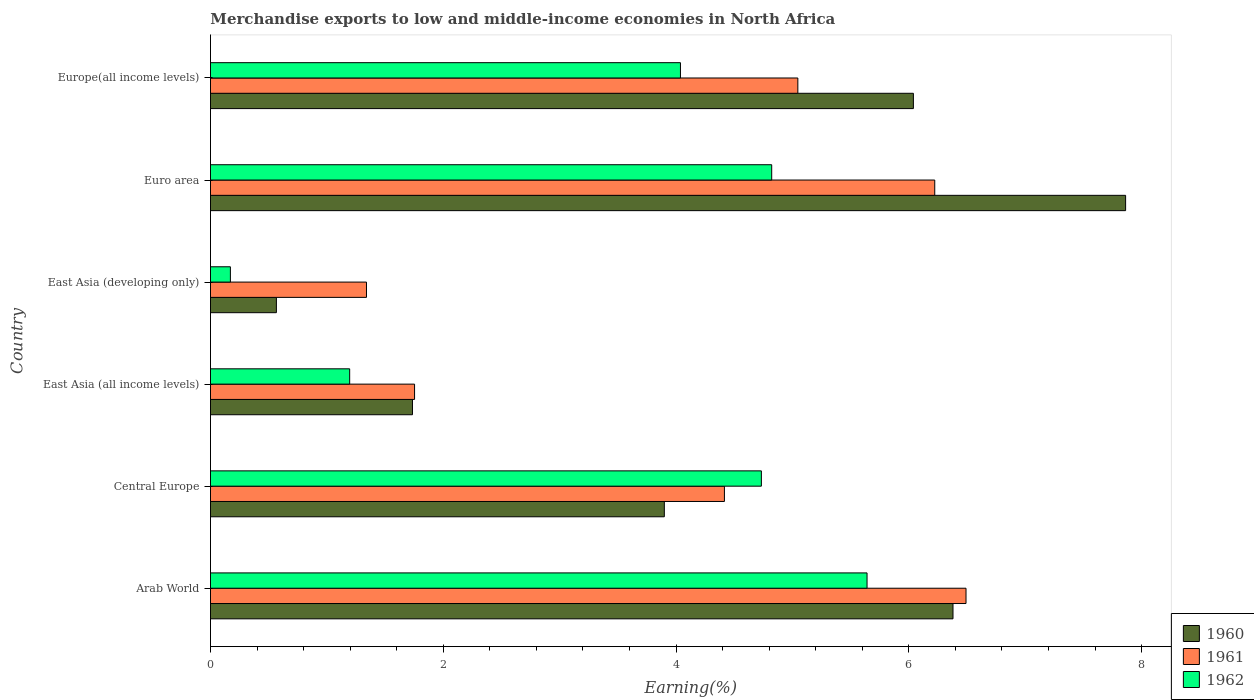How many groups of bars are there?
Offer a terse response. 6. Are the number of bars per tick equal to the number of legend labels?
Your response must be concise. Yes. Are the number of bars on each tick of the Y-axis equal?
Give a very brief answer. Yes. How many bars are there on the 3rd tick from the top?
Your response must be concise. 3. What is the label of the 4th group of bars from the top?
Your answer should be very brief. East Asia (all income levels). In how many cases, is the number of bars for a given country not equal to the number of legend labels?
Your answer should be compact. 0. What is the percentage of amount earned from merchandise exports in 1962 in Europe(all income levels)?
Your response must be concise. 4.04. Across all countries, what is the maximum percentage of amount earned from merchandise exports in 1961?
Your response must be concise. 6.49. Across all countries, what is the minimum percentage of amount earned from merchandise exports in 1960?
Ensure brevity in your answer.  0.57. In which country was the percentage of amount earned from merchandise exports in 1961 maximum?
Your answer should be very brief. Arab World. In which country was the percentage of amount earned from merchandise exports in 1960 minimum?
Give a very brief answer. East Asia (developing only). What is the total percentage of amount earned from merchandise exports in 1962 in the graph?
Your answer should be very brief. 20.6. What is the difference between the percentage of amount earned from merchandise exports in 1962 in Arab World and that in Euro area?
Provide a short and direct response. 0.82. What is the difference between the percentage of amount earned from merchandise exports in 1962 in Euro area and the percentage of amount earned from merchandise exports in 1960 in East Asia (all income levels)?
Offer a very short reply. 3.09. What is the average percentage of amount earned from merchandise exports in 1961 per country?
Ensure brevity in your answer.  4.21. What is the difference between the percentage of amount earned from merchandise exports in 1962 and percentage of amount earned from merchandise exports in 1961 in Central Europe?
Make the answer very short. 0.32. What is the ratio of the percentage of amount earned from merchandise exports in 1962 in East Asia (all income levels) to that in Europe(all income levels)?
Ensure brevity in your answer.  0.3. Is the difference between the percentage of amount earned from merchandise exports in 1962 in East Asia (all income levels) and Euro area greater than the difference between the percentage of amount earned from merchandise exports in 1961 in East Asia (all income levels) and Euro area?
Your response must be concise. Yes. What is the difference between the highest and the second highest percentage of amount earned from merchandise exports in 1962?
Ensure brevity in your answer.  0.82. What is the difference between the highest and the lowest percentage of amount earned from merchandise exports in 1960?
Keep it short and to the point. 7.3. How many countries are there in the graph?
Offer a very short reply. 6. What is the difference between two consecutive major ticks on the X-axis?
Make the answer very short. 2. Does the graph contain any zero values?
Ensure brevity in your answer.  No. What is the title of the graph?
Your answer should be very brief. Merchandise exports to low and middle-income economies in North Africa. What is the label or title of the X-axis?
Provide a short and direct response. Earning(%). What is the Earning(%) of 1960 in Arab World?
Provide a succinct answer. 6.38. What is the Earning(%) in 1961 in Arab World?
Your answer should be compact. 6.49. What is the Earning(%) of 1962 in Arab World?
Keep it short and to the point. 5.64. What is the Earning(%) in 1960 in Central Europe?
Give a very brief answer. 3.9. What is the Earning(%) of 1961 in Central Europe?
Keep it short and to the point. 4.42. What is the Earning(%) of 1962 in Central Europe?
Provide a short and direct response. 4.73. What is the Earning(%) of 1960 in East Asia (all income levels)?
Keep it short and to the point. 1.74. What is the Earning(%) of 1961 in East Asia (all income levels)?
Your response must be concise. 1.75. What is the Earning(%) in 1962 in East Asia (all income levels)?
Give a very brief answer. 1.2. What is the Earning(%) in 1960 in East Asia (developing only)?
Ensure brevity in your answer.  0.57. What is the Earning(%) in 1961 in East Asia (developing only)?
Make the answer very short. 1.34. What is the Earning(%) of 1962 in East Asia (developing only)?
Provide a succinct answer. 0.17. What is the Earning(%) of 1960 in Euro area?
Your response must be concise. 7.86. What is the Earning(%) in 1961 in Euro area?
Your response must be concise. 6.22. What is the Earning(%) of 1962 in Euro area?
Provide a succinct answer. 4.82. What is the Earning(%) of 1960 in Europe(all income levels)?
Offer a terse response. 6.04. What is the Earning(%) in 1961 in Europe(all income levels)?
Offer a terse response. 5.05. What is the Earning(%) in 1962 in Europe(all income levels)?
Offer a very short reply. 4.04. Across all countries, what is the maximum Earning(%) of 1960?
Offer a very short reply. 7.86. Across all countries, what is the maximum Earning(%) of 1961?
Your answer should be compact. 6.49. Across all countries, what is the maximum Earning(%) of 1962?
Your answer should be very brief. 5.64. Across all countries, what is the minimum Earning(%) in 1960?
Offer a terse response. 0.57. Across all countries, what is the minimum Earning(%) of 1961?
Make the answer very short. 1.34. Across all countries, what is the minimum Earning(%) of 1962?
Ensure brevity in your answer.  0.17. What is the total Earning(%) in 1960 in the graph?
Offer a very short reply. 26.48. What is the total Earning(%) in 1961 in the graph?
Keep it short and to the point. 25.27. What is the total Earning(%) of 1962 in the graph?
Offer a terse response. 20.6. What is the difference between the Earning(%) of 1960 in Arab World and that in Central Europe?
Offer a very short reply. 2.48. What is the difference between the Earning(%) in 1961 in Arab World and that in Central Europe?
Your answer should be compact. 2.08. What is the difference between the Earning(%) in 1962 in Arab World and that in Central Europe?
Make the answer very short. 0.91. What is the difference between the Earning(%) in 1960 in Arab World and that in East Asia (all income levels)?
Provide a short and direct response. 4.64. What is the difference between the Earning(%) in 1961 in Arab World and that in East Asia (all income levels)?
Your answer should be compact. 4.74. What is the difference between the Earning(%) of 1962 in Arab World and that in East Asia (all income levels)?
Offer a terse response. 4.45. What is the difference between the Earning(%) in 1960 in Arab World and that in East Asia (developing only)?
Your answer should be very brief. 5.81. What is the difference between the Earning(%) of 1961 in Arab World and that in East Asia (developing only)?
Your answer should be compact. 5.15. What is the difference between the Earning(%) of 1962 in Arab World and that in East Asia (developing only)?
Your response must be concise. 5.47. What is the difference between the Earning(%) in 1960 in Arab World and that in Euro area?
Keep it short and to the point. -1.48. What is the difference between the Earning(%) in 1961 in Arab World and that in Euro area?
Offer a terse response. 0.27. What is the difference between the Earning(%) in 1962 in Arab World and that in Euro area?
Provide a short and direct response. 0.82. What is the difference between the Earning(%) in 1960 in Arab World and that in Europe(all income levels)?
Your answer should be very brief. 0.34. What is the difference between the Earning(%) in 1961 in Arab World and that in Europe(all income levels)?
Offer a terse response. 1.44. What is the difference between the Earning(%) of 1962 in Arab World and that in Europe(all income levels)?
Ensure brevity in your answer.  1.6. What is the difference between the Earning(%) in 1960 in Central Europe and that in East Asia (all income levels)?
Provide a succinct answer. 2.16. What is the difference between the Earning(%) in 1961 in Central Europe and that in East Asia (all income levels)?
Offer a very short reply. 2.66. What is the difference between the Earning(%) in 1962 in Central Europe and that in East Asia (all income levels)?
Offer a very short reply. 3.54. What is the difference between the Earning(%) of 1960 in Central Europe and that in East Asia (developing only)?
Offer a very short reply. 3.33. What is the difference between the Earning(%) of 1961 in Central Europe and that in East Asia (developing only)?
Provide a short and direct response. 3.08. What is the difference between the Earning(%) of 1962 in Central Europe and that in East Asia (developing only)?
Your answer should be very brief. 4.56. What is the difference between the Earning(%) of 1960 in Central Europe and that in Euro area?
Make the answer very short. -3.96. What is the difference between the Earning(%) in 1961 in Central Europe and that in Euro area?
Provide a succinct answer. -1.81. What is the difference between the Earning(%) in 1962 in Central Europe and that in Euro area?
Ensure brevity in your answer.  -0.09. What is the difference between the Earning(%) in 1960 in Central Europe and that in Europe(all income levels)?
Ensure brevity in your answer.  -2.14. What is the difference between the Earning(%) of 1961 in Central Europe and that in Europe(all income levels)?
Provide a succinct answer. -0.63. What is the difference between the Earning(%) of 1962 in Central Europe and that in Europe(all income levels)?
Provide a succinct answer. 0.7. What is the difference between the Earning(%) in 1960 in East Asia (all income levels) and that in East Asia (developing only)?
Provide a short and direct response. 1.17. What is the difference between the Earning(%) of 1961 in East Asia (all income levels) and that in East Asia (developing only)?
Provide a succinct answer. 0.41. What is the difference between the Earning(%) of 1962 in East Asia (all income levels) and that in East Asia (developing only)?
Provide a short and direct response. 1.02. What is the difference between the Earning(%) in 1960 in East Asia (all income levels) and that in Euro area?
Your answer should be compact. -6.13. What is the difference between the Earning(%) in 1961 in East Asia (all income levels) and that in Euro area?
Offer a terse response. -4.47. What is the difference between the Earning(%) in 1962 in East Asia (all income levels) and that in Euro area?
Offer a terse response. -3.63. What is the difference between the Earning(%) in 1960 in East Asia (all income levels) and that in Europe(all income levels)?
Provide a short and direct response. -4.3. What is the difference between the Earning(%) in 1961 in East Asia (all income levels) and that in Europe(all income levels)?
Your answer should be compact. -3.29. What is the difference between the Earning(%) in 1962 in East Asia (all income levels) and that in Europe(all income levels)?
Offer a very short reply. -2.84. What is the difference between the Earning(%) of 1960 in East Asia (developing only) and that in Euro area?
Your answer should be compact. -7.3. What is the difference between the Earning(%) in 1961 in East Asia (developing only) and that in Euro area?
Ensure brevity in your answer.  -4.88. What is the difference between the Earning(%) in 1962 in East Asia (developing only) and that in Euro area?
Offer a very short reply. -4.65. What is the difference between the Earning(%) of 1960 in East Asia (developing only) and that in Europe(all income levels)?
Provide a short and direct response. -5.47. What is the difference between the Earning(%) of 1961 in East Asia (developing only) and that in Europe(all income levels)?
Keep it short and to the point. -3.71. What is the difference between the Earning(%) in 1962 in East Asia (developing only) and that in Europe(all income levels)?
Keep it short and to the point. -3.87. What is the difference between the Earning(%) of 1960 in Euro area and that in Europe(all income levels)?
Ensure brevity in your answer.  1.82. What is the difference between the Earning(%) of 1961 in Euro area and that in Europe(all income levels)?
Give a very brief answer. 1.18. What is the difference between the Earning(%) of 1962 in Euro area and that in Europe(all income levels)?
Your answer should be compact. 0.78. What is the difference between the Earning(%) of 1960 in Arab World and the Earning(%) of 1961 in Central Europe?
Your response must be concise. 1.96. What is the difference between the Earning(%) in 1960 in Arab World and the Earning(%) in 1962 in Central Europe?
Your answer should be very brief. 1.65. What is the difference between the Earning(%) of 1961 in Arab World and the Earning(%) of 1962 in Central Europe?
Your answer should be compact. 1.76. What is the difference between the Earning(%) of 1960 in Arab World and the Earning(%) of 1961 in East Asia (all income levels)?
Offer a very short reply. 4.63. What is the difference between the Earning(%) in 1960 in Arab World and the Earning(%) in 1962 in East Asia (all income levels)?
Provide a succinct answer. 5.18. What is the difference between the Earning(%) in 1961 in Arab World and the Earning(%) in 1962 in East Asia (all income levels)?
Offer a very short reply. 5.3. What is the difference between the Earning(%) of 1960 in Arab World and the Earning(%) of 1961 in East Asia (developing only)?
Your response must be concise. 5.04. What is the difference between the Earning(%) of 1960 in Arab World and the Earning(%) of 1962 in East Asia (developing only)?
Give a very brief answer. 6.21. What is the difference between the Earning(%) in 1961 in Arab World and the Earning(%) in 1962 in East Asia (developing only)?
Make the answer very short. 6.32. What is the difference between the Earning(%) in 1960 in Arab World and the Earning(%) in 1961 in Euro area?
Your answer should be compact. 0.16. What is the difference between the Earning(%) of 1960 in Arab World and the Earning(%) of 1962 in Euro area?
Provide a succinct answer. 1.56. What is the difference between the Earning(%) of 1961 in Arab World and the Earning(%) of 1962 in Euro area?
Your response must be concise. 1.67. What is the difference between the Earning(%) in 1960 in Arab World and the Earning(%) in 1961 in Europe(all income levels)?
Provide a succinct answer. 1.33. What is the difference between the Earning(%) in 1960 in Arab World and the Earning(%) in 1962 in Europe(all income levels)?
Keep it short and to the point. 2.34. What is the difference between the Earning(%) of 1961 in Arab World and the Earning(%) of 1962 in Europe(all income levels)?
Offer a very short reply. 2.45. What is the difference between the Earning(%) in 1960 in Central Europe and the Earning(%) in 1961 in East Asia (all income levels)?
Your answer should be very brief. 2.15. What is the difference between the Earning(%) in 1960 in Central Europe and the Earning(%) in 1962 in East Asia (all income levels)?
Provide a succinct answer. 2.7. What is the difference between the Earning(%) in 1961 in Central Europe and the Earning(%) in 1962 in East Asia (all income levels)?
Your answer should be very brief. 3.22. What is the difference between the Earning(%) of 1960 in Central Europe and the Earning(%) of 1961 in East Asia (developing only)?
Offer a very short reply. 2.56. What is the difference between the Earning(%) in 1960 in Central Europe and the Earning(%) in 1962 in East Asia (developing only)?
Offer a terse response. 3.73. What is the difference between the Earning(%) in 1961 in Central Europe and the Earning(%) in 1962 in East Asia (developing only)?
Give a very brief answer. 4.24. What is the difference between the Earning(%) of 1960 in Central Europe and the Earning(%) of 1961 in Euro area?
Offer a terse response. -2.32. What is the difference between the Earning(%) in 1960 in Central Europe and the Earning(%) in 1962 in Euro area?
Keep it short and to the point. -0.92. What is the difference between the Earning(%) in 1961 in Central Europe and the Earning(%) in 1962 in Euro area?
Provide a succinct answer. -0.41. What is the difference between the Earning(%) in 1960 in Central Europe and the Earning(%) in 1961 in Europe(all income levels)?
Offer a terse response. -1.15. What is the difference between the Earning(%) in 1960 in Central Europe and the Earning(%) in 1962 in Europe(all income levels)?
Offer a terse response. -0.14. What is the difference between the Earning(%) in 1961 in Central Europe and the Earning(%) in 1962 in Europe(all income levels)?
Offer a very short reply. 0.38. What is the difference between the Earning(%) in 1960 in East Asia (all income levels) and the Earning(%) in 1961 in East Asia (developing only)?
Your answer should be compact. 0.4. What is the difference between the Earning(%) in 1960 in East Asia (all income levels) and the Earning(%) in 1962 in East Asia (developing only)?
Your response must be concise. 1.56. What is the difference between the Earning(%) in 1961 in East Asia (all income levels) and the Earning(%) in 1962 in East Asia (developing only)?
Provide a succinct answer. 1.58. What is the difference between the Earning(%) of 1960 in East Asia (all income levels) and the Earning(%) of 1961 in Euro area?
Provide a short and direct response. -4.49. What is the difference between the Earning(%) in 1960 in East Asia (all income levels) and the Earning(%) in 1962 in Euro area?
Offer a very short reply. -3.09. What is the difference between the Earning(%) of 1961 in East Asia (all income levels) and the Earning(%) of 1962 in Euro area?
Give a very brief answer. -3.07. What is the difference between the Earning(%) in 1960 in East Asia (all income levels) and the Earning(%) in 1961 in Europe(all income levels)?
Your answer should be very brief. -3.31. What is the difference between the Earning(%) in 1960 in East Asia (all income levels) and the Earning(%) in 1962 in Europe(all income levels)?
Keep it short and to the point. -2.3. What is the difference between the Earning(%) in 1961 in East Asia (all income levels) and the Earning(%) in 1962 in Europe(all income levels)?
Provide a succinct answer. -2.28. What is the difference between the Earning(%) in 1960 in East Asia (developing only) and the Earning(%) in 1961 in Euro area?
Your response must be concise. -5.66. What is the difference between the Earning(%) of 1960 in East Asia (developing only) and the Earning(%) of 1962 in Euro area?
Offer a terse response. -4.26. What is the difference between the Earning(%) of 1961 in East Asia (developing only) and the Earning(%) of 1962 in Euro area?
Your answer should be compact. -3.48. What is the difference between the Earning(%) in 1960 in East Asia (developing only) and the Earning(%) in 1961 in Europe(all income levels)?
Provide a succinct answer. -4.48. What is the difference between the Earning(%) of 1960 in East Asia (developing only) and the Earning(%) of 1962 in Europe(all income levels)?
Provide a short and direct response. -3.47. What is the difference between the Earning(%) in 1961 in East Asia (developing only) and the Earning(%) in 1962 in Europe(all income levels)?
Provide a short and direct response. -2.7. What is the difference between the Earning(%) of 1960 in Euro area and the Earning(%) of 1961 in Europe(all income levels)?
Offer a terse response. 2.82. What is the difference between the Earning(%) of 1960 in Euro area and the Earning(%) of 1962 in Europe(all income levels)?
Ensure brevity in your answer.  3.82. What is the difference between the Earning(%) in 1961 in Euro area and the Earning(%) in 1962 in Europe(all income levels)?
Provide a succinct answer. 2.18. What is the average Earning(%) in 1960 per country?
Your answer should be very brief. 4.41. What is the average Earning(%) in 1961 per country?
Your answer should be compact. 4.21. What is the average Earning(%) of 1962 per country?
Your answer should be compact. 3.43. What is the difference between the Earning(%) in 1960 and Earning(%) in 1961 in Arab World?
Give a very brief answer. -0.11. What is the difference between the Earning(%) of 1960 and Earning(%) of 1962 in Arab World?
Provide a succinct answer. 0.74. What is the difference between the Earning(%) of 1961 and Earning(%) of 1962 in Arab World?
Keep it short and to the point. 0.85. What is the difference between the Earning(%) of 1960 and Earning(%) of 1961 in Central Europe?
Offer a very short reply. -0.52. What is the difference between the Earning(%) of 1960 and Earning(%) of 1962 in Central Europe?
Provide a short and direct response. -0.83. What is the difference between the Earning(%) of 1961 and Earning(%) of 1962 in Central Europe?
Provide a succinct answer. -0.32. What is the difference between the Earning(%) of 1960 and Earning(%) of 1961 in East Asia (all income levels)?
Offer a very short reply. -0.02. What is the difference between the Earning(%) of 1960 and Earning(%) of 1962 in East Asia (all income levels)?
Give a very brief answer. 0.54. What is the difference between the Earning(%) of 1961 and Earning(%) of 1962 in East Asia (all income levels)?
Offer a terse response. 0.56. What is the difference between the Earning(%) in 1960 and Earning(%) in 1961 in East Asia (developing only)?
Provide a succinct answer. -0.77. What is the difference between the Earning(%) in 1960 and Earning(%) in 1962 in East Asia (developing only)?
Give a very brief answer. 0.4. What is the difference between the Earning(%) of 1961 and Earning(%) of 1962 in East Asia (developing only)?
Your response must be concise. 1.17. What is the difference between the Earning(%) in 1960 and Earning(%) in 1961 in Euro area?
Keep it short and to the point. 1.64. What is the difference between the Earning(%) in 1960 and Earning(%) in 1962 in Euro area?
Keep it short and to the point. 3.04. What is the difference between the Earning(%) in 1961 and Earning(%) in 1962 in Euro area?
Ensure brevity in your answer.  1.4. What is the difference between the Earning(%) in 1960 and Earning(%) in 1962 in Europe(all income levels)?
Give a very brief answer. 2. What is the difference between the Earning(%) of 1961 and Earning(%) of 1962 in Europe(all income levels)?
Provide a short and direct response. 1.01. What is the ratio of the Earning(%) in 1960 in Arab World to that in Central Europe?
Offer a terse response. 1.64. What is the ratio of the Earning(%) in 1961 in Arab World to that in Central Europe?
Provide a short and direct response. 1.47. What is the ratio of the Earning(%) of 1962 in Arab World to that in Central Europe?
Your answer should be very brief. 1.19. What is the ratio of the Earning(%) in 1960 in Arab World to that in East Asia (all income levels)?
Make the answer very short. 3.68. What is the ratio of the Earning(%) in 1961 in Arab World to that in East Asia (all income levels)?
Provide a short and direct response. 3.7. What is the ratio of the Earning(%) of 1962 in Arab World to that in East Asia (all income levels)?
Give a very brief answer. 4.72. What is the ratio of the Earning(%) of 1960 in Arab World to that in East Asia (developing only)?
Offer a terse response. 11.27. What is the ratio of the Earning(%) in 1961 in Arab World to that in East Asia (developing only)?
Your answer should be very brief. 4.84. What is the ratio of the Earning(%) of 1962 in Arab World to that in East Asia (developing only)?
Your answer should be very brief. 32.97. What is the ratio of the Earning(%) of 1960 in Arab World to that in Euro area?
Make the answer very short. 0.81. What is the ratio of the Earning(%) in 1961 in Arab World to that in Euro area?
Your answer should be very brief. 1.04. What is the ratio of the Earning(%) in 1962 in Arab World to that in Euro area?
Your response must be concise. 1.17. What is the ratio of the Earning(%) of 1960 in Arab World to that in Europe(all income levels)?
Your response must be concise. 1.06. What is the ratio of the Earning(%) in 1961 in Arab World to that in Europe(all income levels)?
Keep it short and to the point. 1.29. What is the ratio of the Earning(%) in 1962 in Arab World to that in Europe(all income levels)?
Make the answer very short. 1.4. What is the ratio of the Earning(%) in 1960 in Central Europe to that in East Asia (all income levels)?
Give a very brief answer. 2.25. What is the ratio of the Earning(%) of 1961 in Central Europe to that in East Asia (all income levels)?
Provide a short and direct response. 2.52. What is the ratio of the Earning(%) of 1962 in Central Europe to that in East Asia (all income levels)?
Provide a short and direct response. 3.96. What is the ratio of the Earning(%) of 1960 in Central Europe to that in East Asia (developing only)?
Your answer should be compact. 6.89. What is the ratio of the Earning(%) in 1961 in Central Europe to that in East Asia (developing only)?
Give a very brief answer. 3.29. What is the ratio of the Earning(%) of 1962 in Central Europe to that in East Asia (developing only)?
Your response must be concise. 27.66. What is the ratio of the Earning(%) in 1960 in Central Europe to that in Euro area?
Your answer should be compact. 0.5. What is the ratio of the Earning(%) in 1961 in Central Europe to that in Euro area?
Give a very brief answer. 0.71. What is the ratio of the Earning(%) in 1962 in Central Europe to that in Euro area?
Your answer should be compact. 0.98. What is the ratio of the Earning(%) of 1960 in Central Europe to that in Europe(all income levels)?
Offer a very short reply. 0.65. What is the ratio of the Earning(%) in 1961 in Central Europe to that in Europe(all income levels)?
Offer a terse response. 0.88. What is the ratio of the Earning(%) in 1962 in Central Europe to that in Europe(all income levels)?
Your response must be concise. 1.17. What is the ratio of the Earning(%) of 1960 in East Asia (all income levels) to that in East Asia (developing only)?
Ensure brevity in your answer.  3.06. What is the ratio of the Earning(%) of 1961 in East Asia (all income levels) to that in East Asia (developing only)?
Make the answer very short. 1.31. What is the ratio of the Earning(%) in 1962 in East Asia (all income levels) to that in East Asia (developing only)?
Offer a very short reply. 6.99. What is the ratio of the Earning(%) in 1960 in East Asia (all income levels) to that in Euro area?
Offer a very short reply. 0.22. What is the ratio of the Earning(%) of 1961 in East Asia (all income levels) to that in Euro area?
Your answer should be compact. 0.28. What is the ratio of the Earning(%) in 1962 in East Asia (all income levels) to that in Euro area?
Make the answer very short. 0.25. What is the ratio of the Earning(%) of 1960 in East Asia (all income levels) to that in Europe(all income levels)?
Your answer should be very brief. 0.29. What is the ratio of the Earning(%) in 1961 in East Asia (all income levels) to that in Europe(all income levels)?
Ensure brevity in your answer.  0.35. What is the ratio of the Earning(%) of 1962 in East Asia (all income levels) to that in Europe(all income levels)?
Provide a short and direct response. 0.3. What is the ratio of the Earning(%) of 1960 in East Asia (developing only) to that in Euro area?
Provide a short and direct response. 0.07. What is the ratio of the Earning(%) of 1961 in East Asia (developing only) to that in Euro area?
Ensure brevity in your answer.  0.22. What is the ratio of the Earning(%) of 1962 in East Asia (developing only) to that in Euro area?
Offer a very short reply. 0.04. What is the ratio of the Earning(%) of 1960 in East Asia (developing only) to that in Europe(all income levels)?
Provide a short and direct response. 0.09. What is the ratio of the Earning(%) of 1961 in East Asia (developing only) to that in Europe(all income levels)?
Offer a terse response. 0.27. What is the ratio of the Earning(%) of 1962 in East Asia (developing only) to that in Europe(all income levels)?
Keep it short and to the point. 0.04. What is the ratio of the Earning(%) in 1960 in Euro area to that in Europe(all income levels)?
Provide a short and direct response. 1.3. What is the ratio of the Earning(%) in 1961 in Euro area to that in Europe(all income levels)?
Your response must be concise. 1.23. What is the ratio of the Earning(%) of 1962 in Euro area to that in Europe(all income levels)?
Offer a very short reply. 1.19. What is the difference between the highest and the second highest Earning(%) of 1960?
Give a very brief answer. 1.48. What is the difference between the highest and the second highest Earning(%) of 1961?
Ensure brevity in your answer.  0.27. What is the difference between the highest and the second highest Earning(%) in 1962?
Provide a short and direct response. 0.82. What is the difference between the highest and the lowest Earning(%) in 1960?
Make the answer very short. 7.3. What is the difference between the highest and the lowest Earning(%) in 1961?
Provide a succinct answer. 5.15. What is the difference between the highest and the lowest Earning(%) in 1962?
Provide a short and direct response. 5.47. 